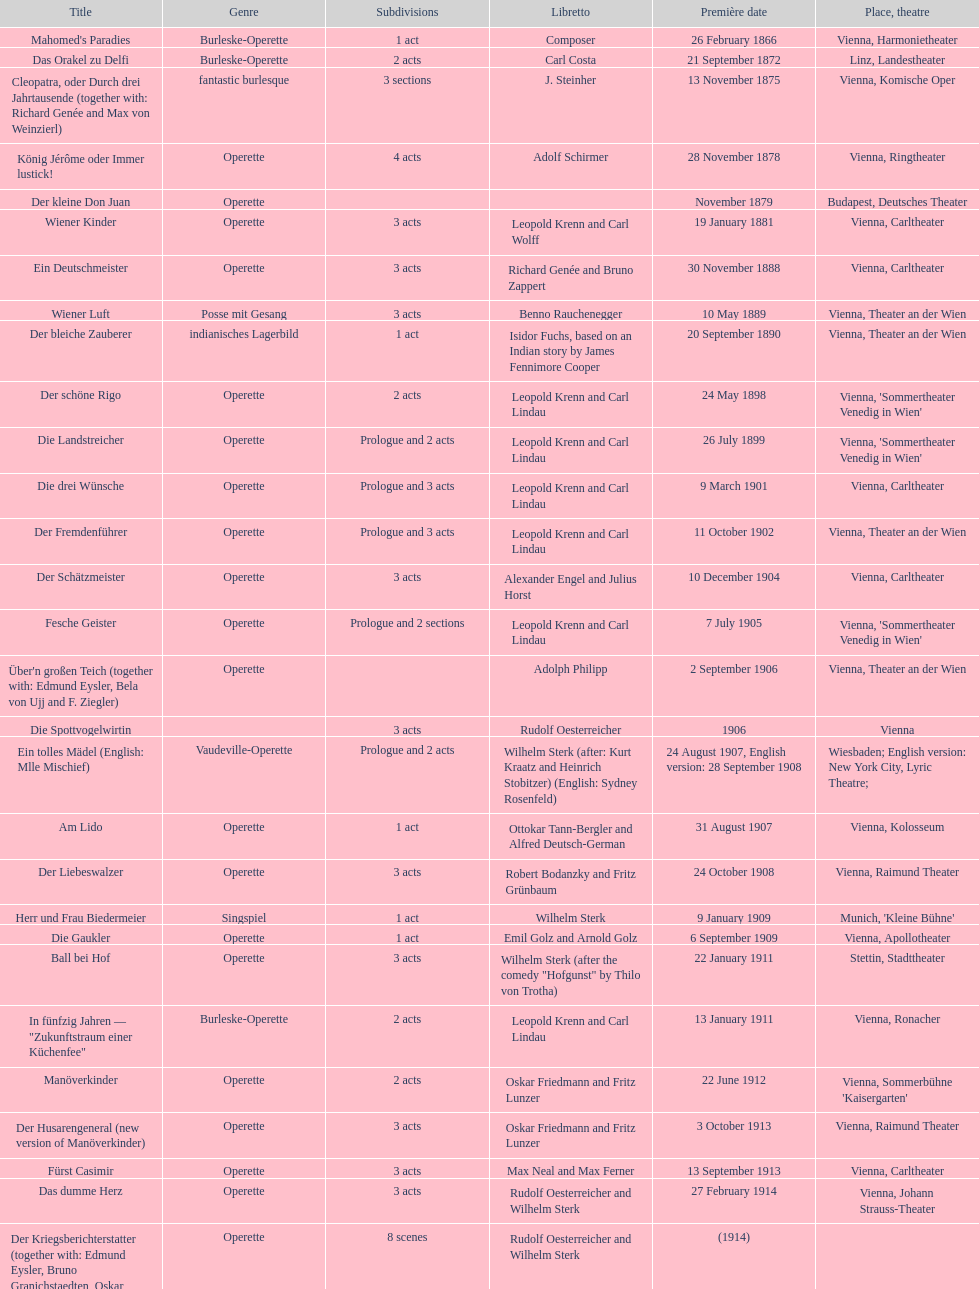What is the quantity of 1 acts that occurred? 5. 